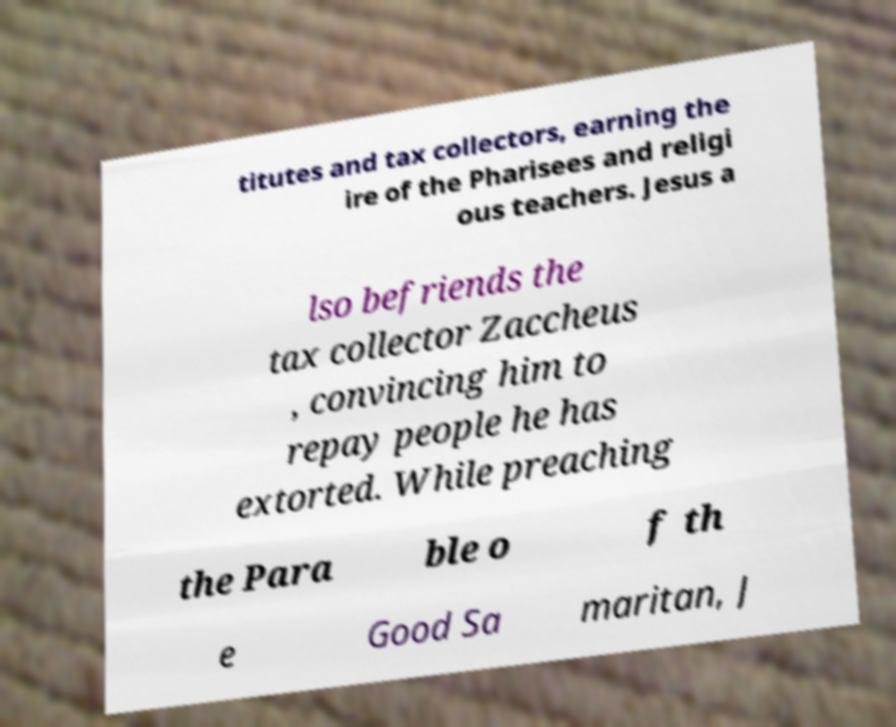Could you extract and type out the text from this image? titutes and tax collectors, earning the ire of the Pharisees and religi ous teachers. Jesus a lso befriends the tax collector Zaccheus , convincing him to repay people he has extorted. While preaching the Para ble o f th e Good Sa maritan, J 